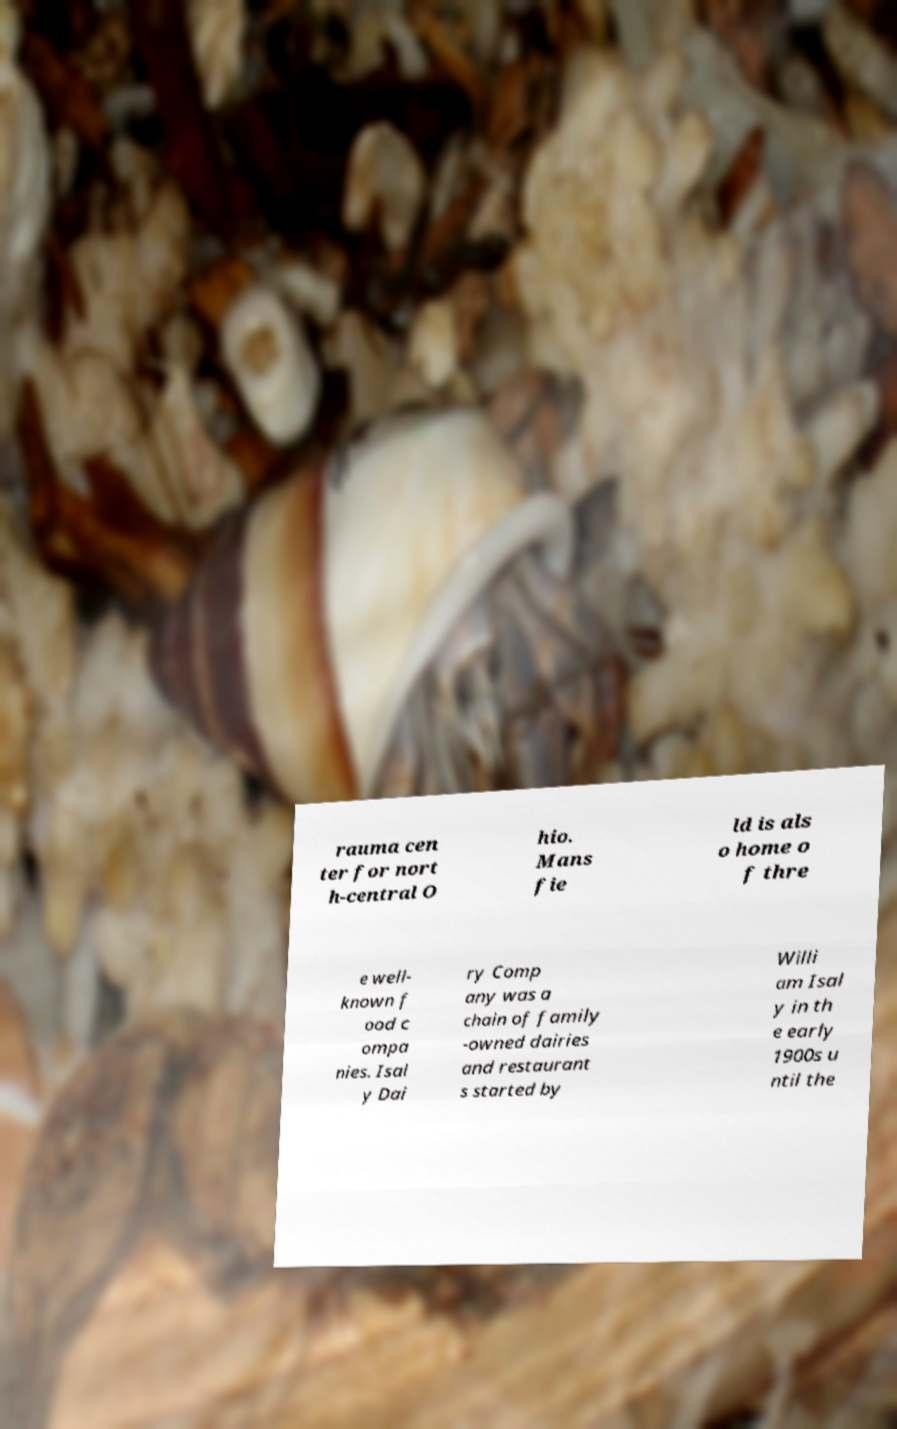Could you assist in decoding the text presented in this image and type it out clearly? rauma cen ter for nort h-central O hio. Mans fie ld is als o home o f thre e well- known f ood c ompa nies. Isal y Dai ry Comp any was a chain of family -owned dairies and restaurant s started by Willi am Isal y in th e early 1900s u ntil the 